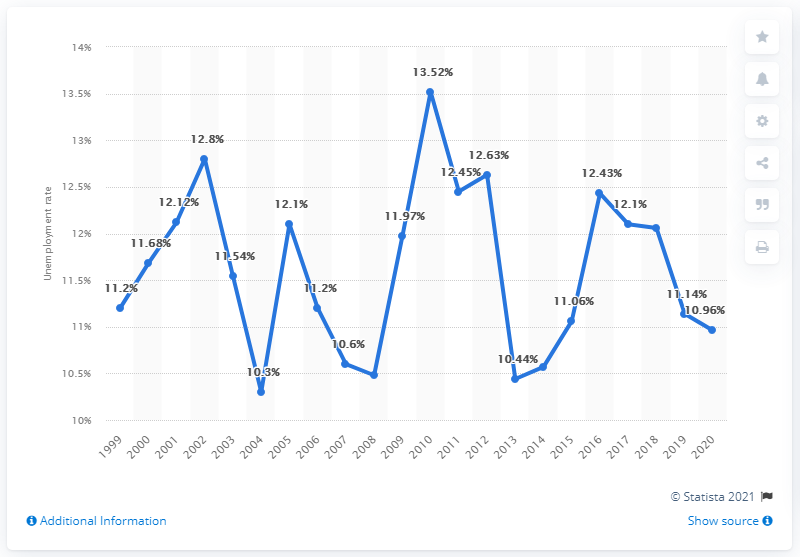Give some essential details in this illustration. In 2020, Iran's unemployment rate was 10.96%. 